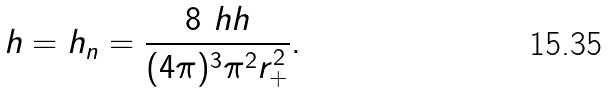Convert formula to latex. <formula><loc_0><loc_0><loc_500><loc_500>h = h _ { n } = \frac { 8 \ h h } { ( 4 \pi ) ^ { 3 } \pi ^ { 2 } r _ { + } ^ { 2 } } .</formula> 